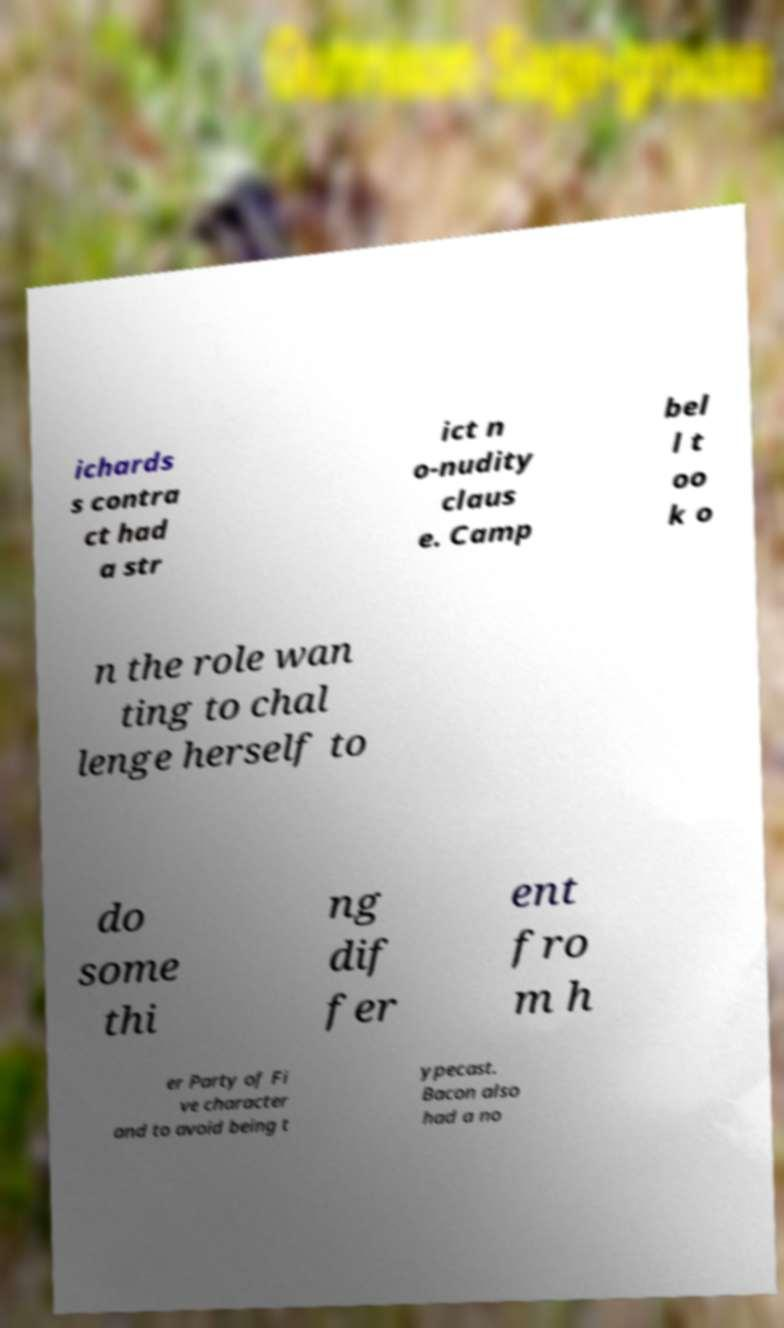What messages or text are displayed in this image? I need them in a readable, typed format. ichards s contra ct had a str ict n o-nudity claus e. Camp bel l t oo k o n the role wan ting to chal lenge herself to do some thi ng dif fer ent fro m h er Party of Fi ve character and to avoid being t ypecast. Bacon also had a no 